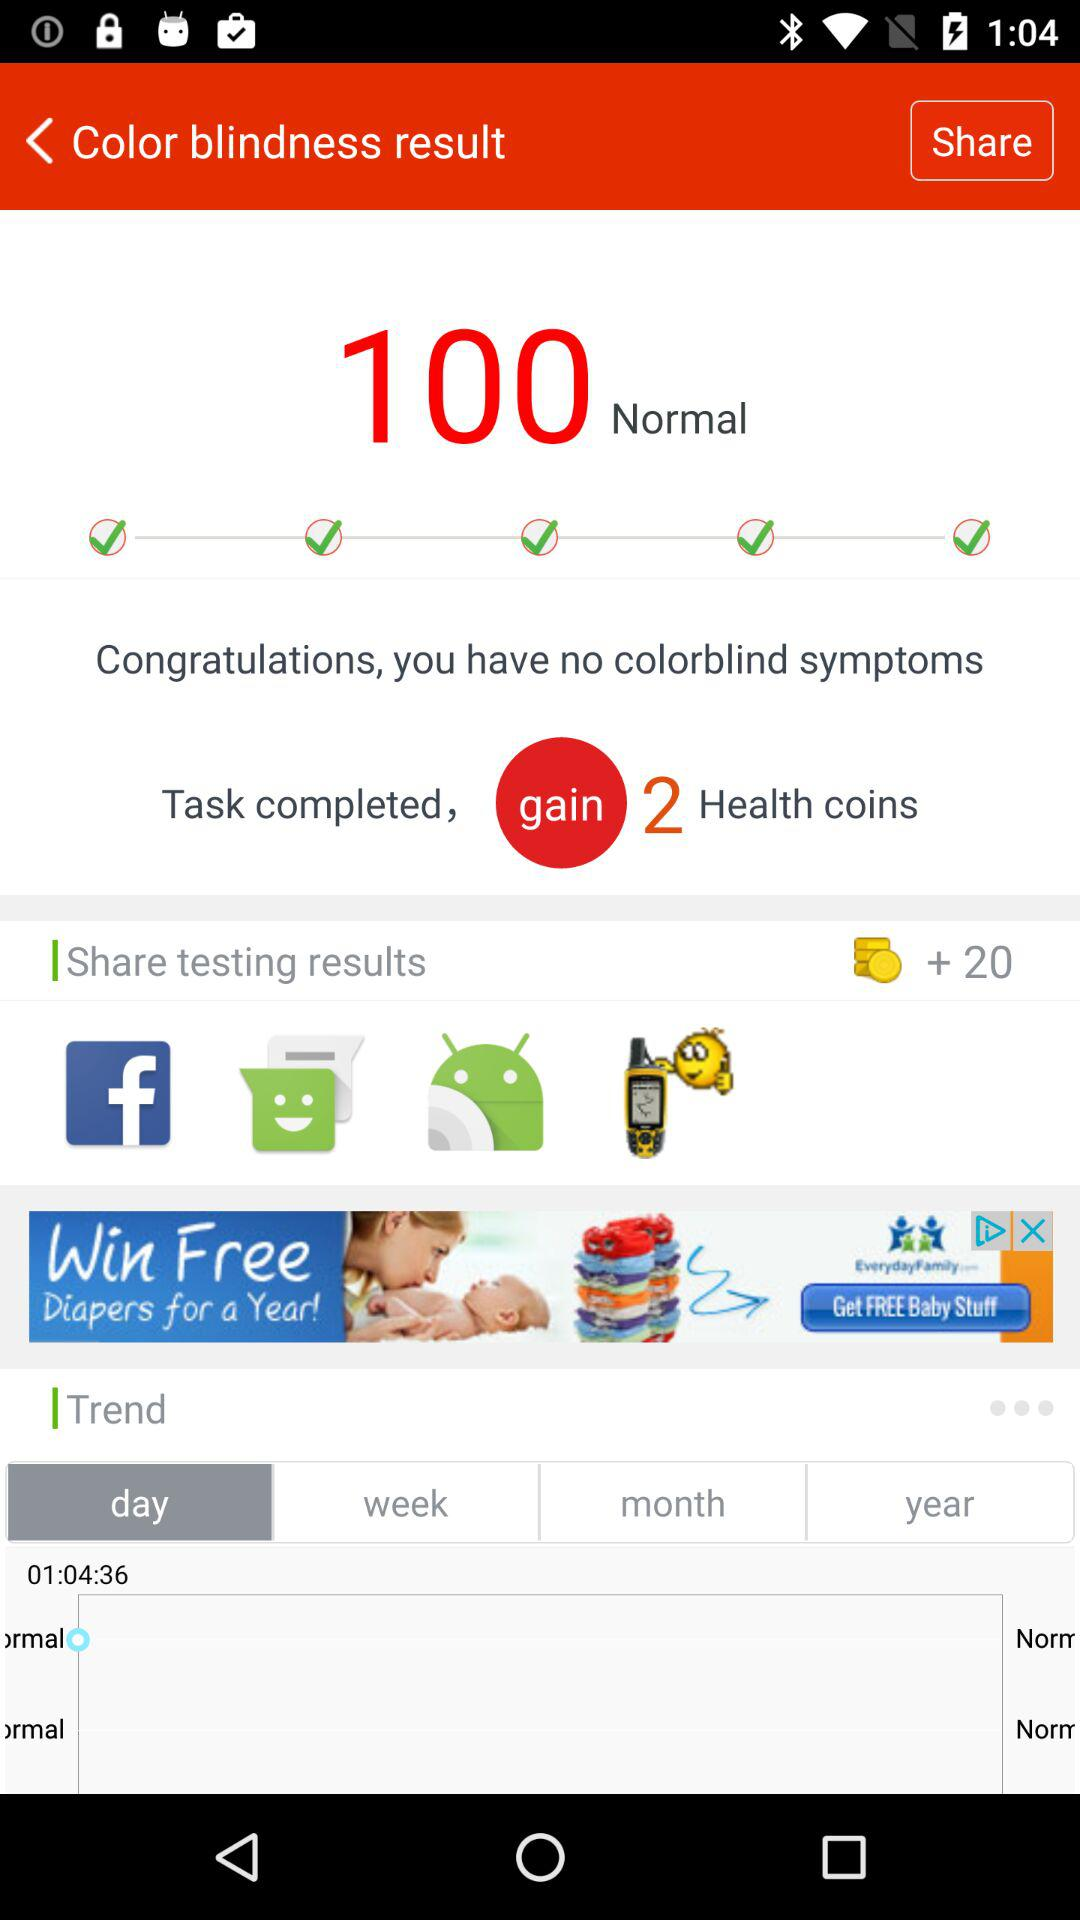What is the result of color blindness? The result is "Normal". 